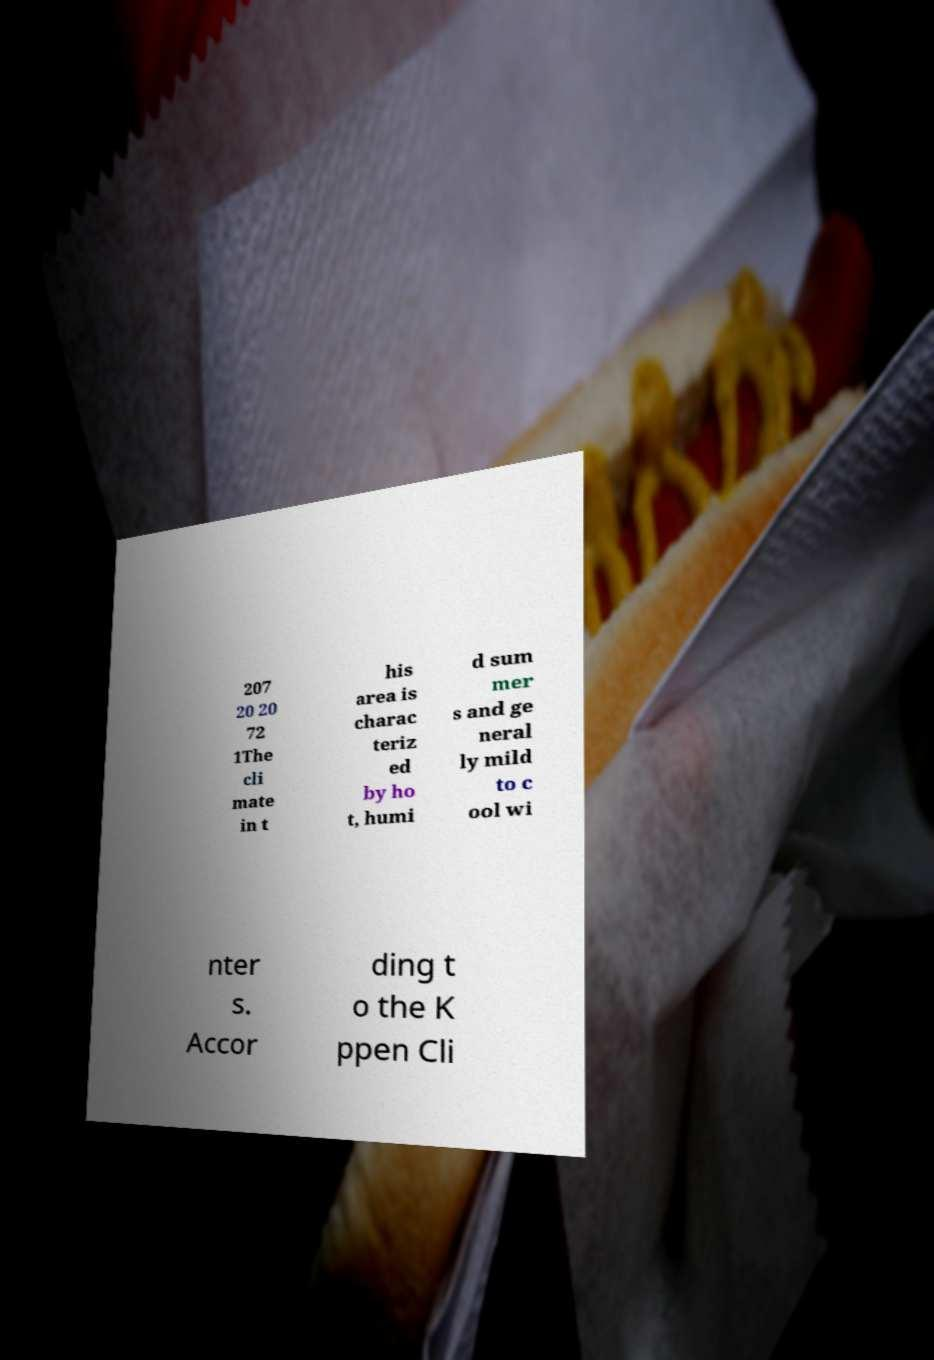What messages or text are displayed in this image? I need them in a readable, typed format. 207 20 20 72 1The cli mate in t his area is charac teriz ed by ho t, humi d sum mer s and ge neral ly mild to c ool wi nter s. Accor ding t o the K ppen Cli 